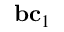Convert formula to latex. <formula><loc_0><loc_0><loc_500><loc_500>b c _ { 1 }</formula> 